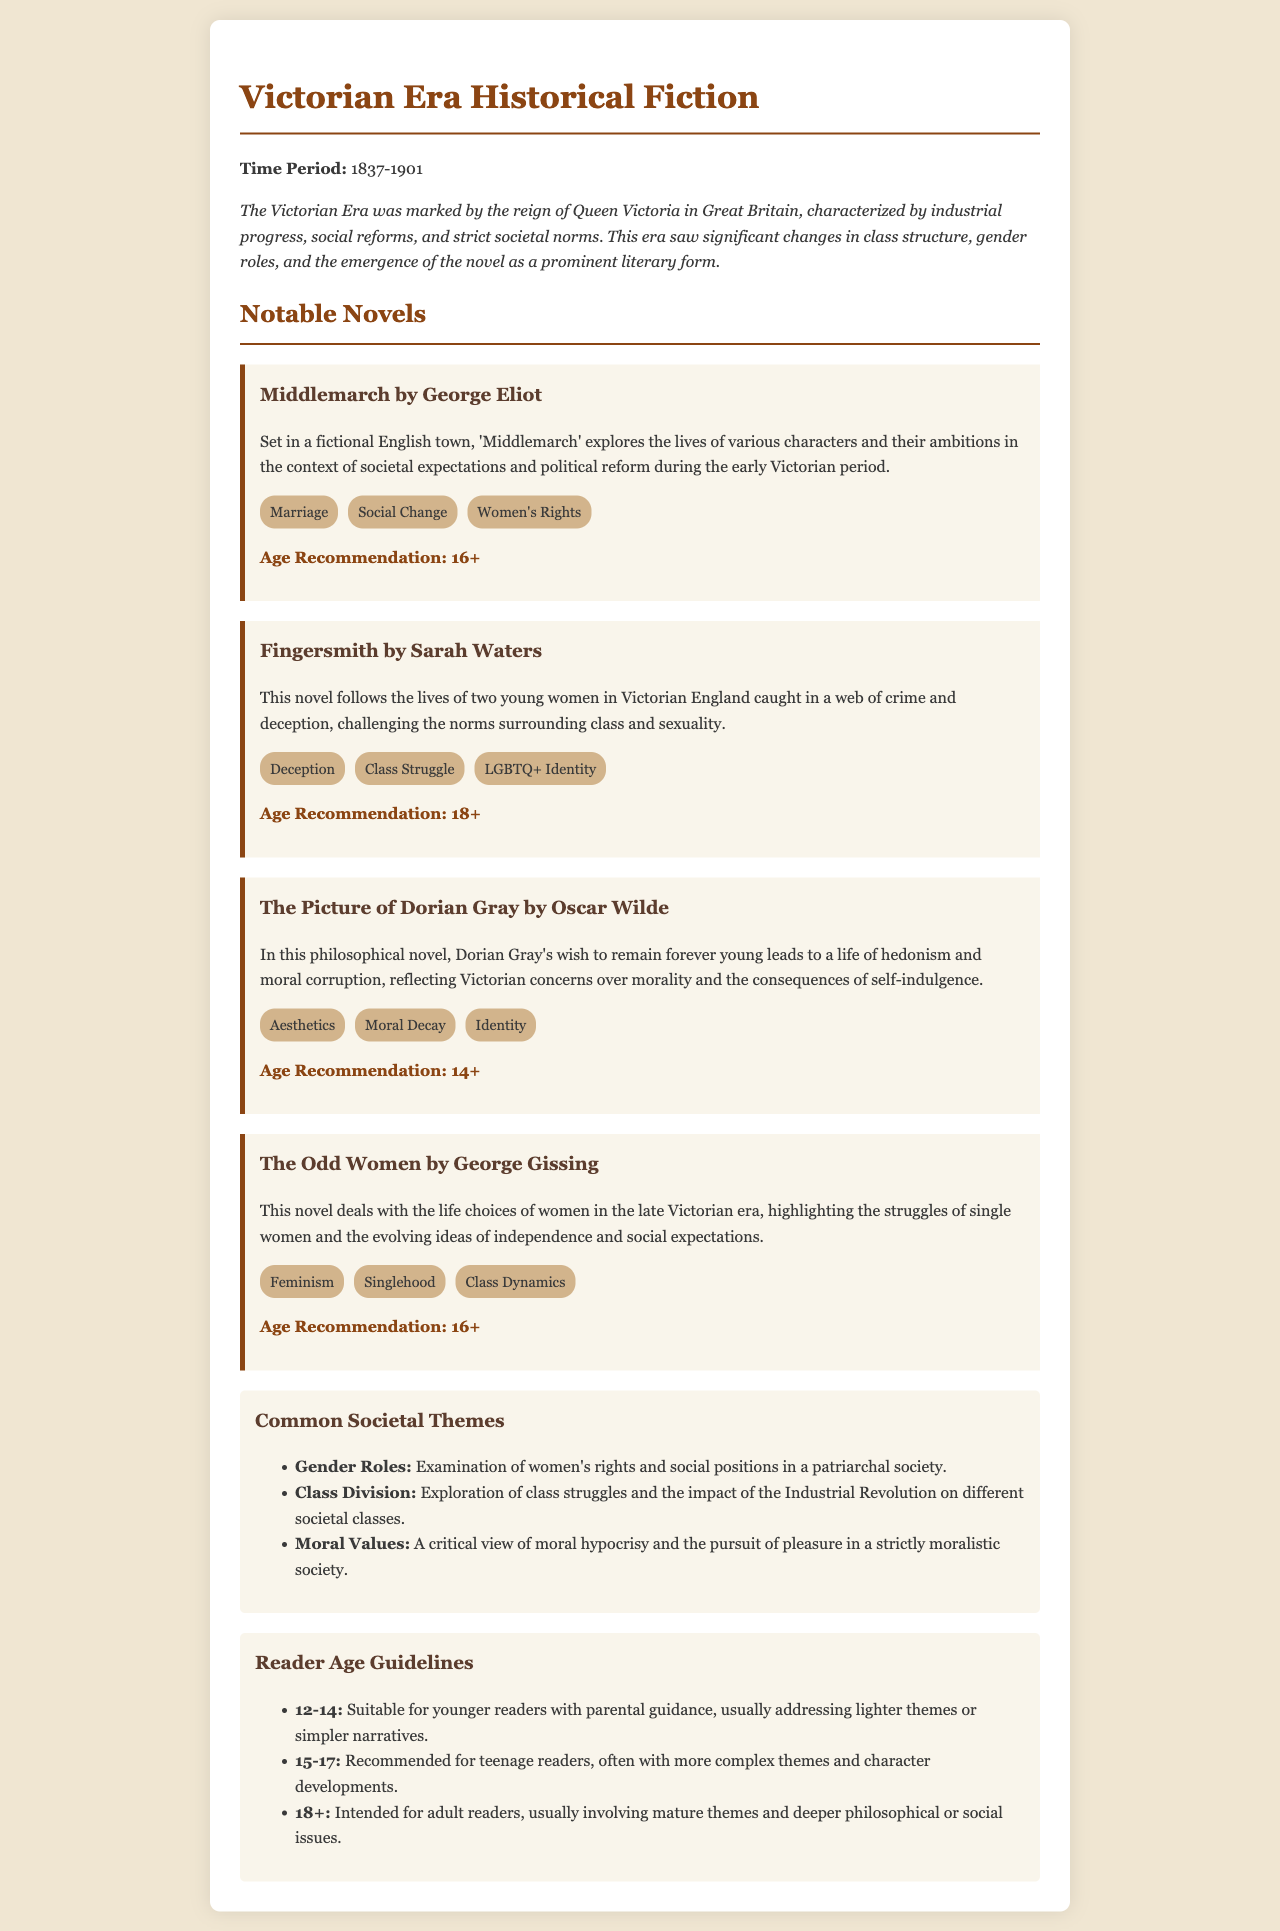What is the time period of the Victorian Era? The document specifies that the Victorian Era lasted from 1837 to 1901.
Answer: 1837-1901 Who wrote "Middlemarch"? The document lists George Eliot as the author of "Middlemarch".
Answer: George Eliot What age is "Fingersmith" recommended for? The age recommendation for "Fingersmith" is clearly stated as 18+.
Answer: 18+ Name one societal theme mentioned in the document. The document lists several themes, such as Gender Roles, Class Division, and Moral Values.
Answer: Gender Roles What are the recommended age guidelines for readers aged 15-17? The document indicates the age guidelines for 15-17-year-olds include complex themes tailored for teenage readers.
Answer: Recommended for teenage readers What type of themes does "The Picture of Dorian Gray" explore? The document describes it exploring aesthetics, moral decay, and identity.
Answer: Aesthetics, Moral Decay, Identity Which novel deals with single women's life choices during late Victorian era? The document specifically mentions "The Odd Women" as dealing with single women's choices.
Answer: The Odd Women What societal theme focuses on the impact of the Industrial Revolution? The document refers to Class Division as the theme focused on the impact of the Industrial Revolution.
Answer: Class Division 